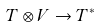Convert formula to latex. <formula><loc_0><loc_0><loc_500><loc_500>T \otimes V \rightarrow T ^ { * }</formula> 